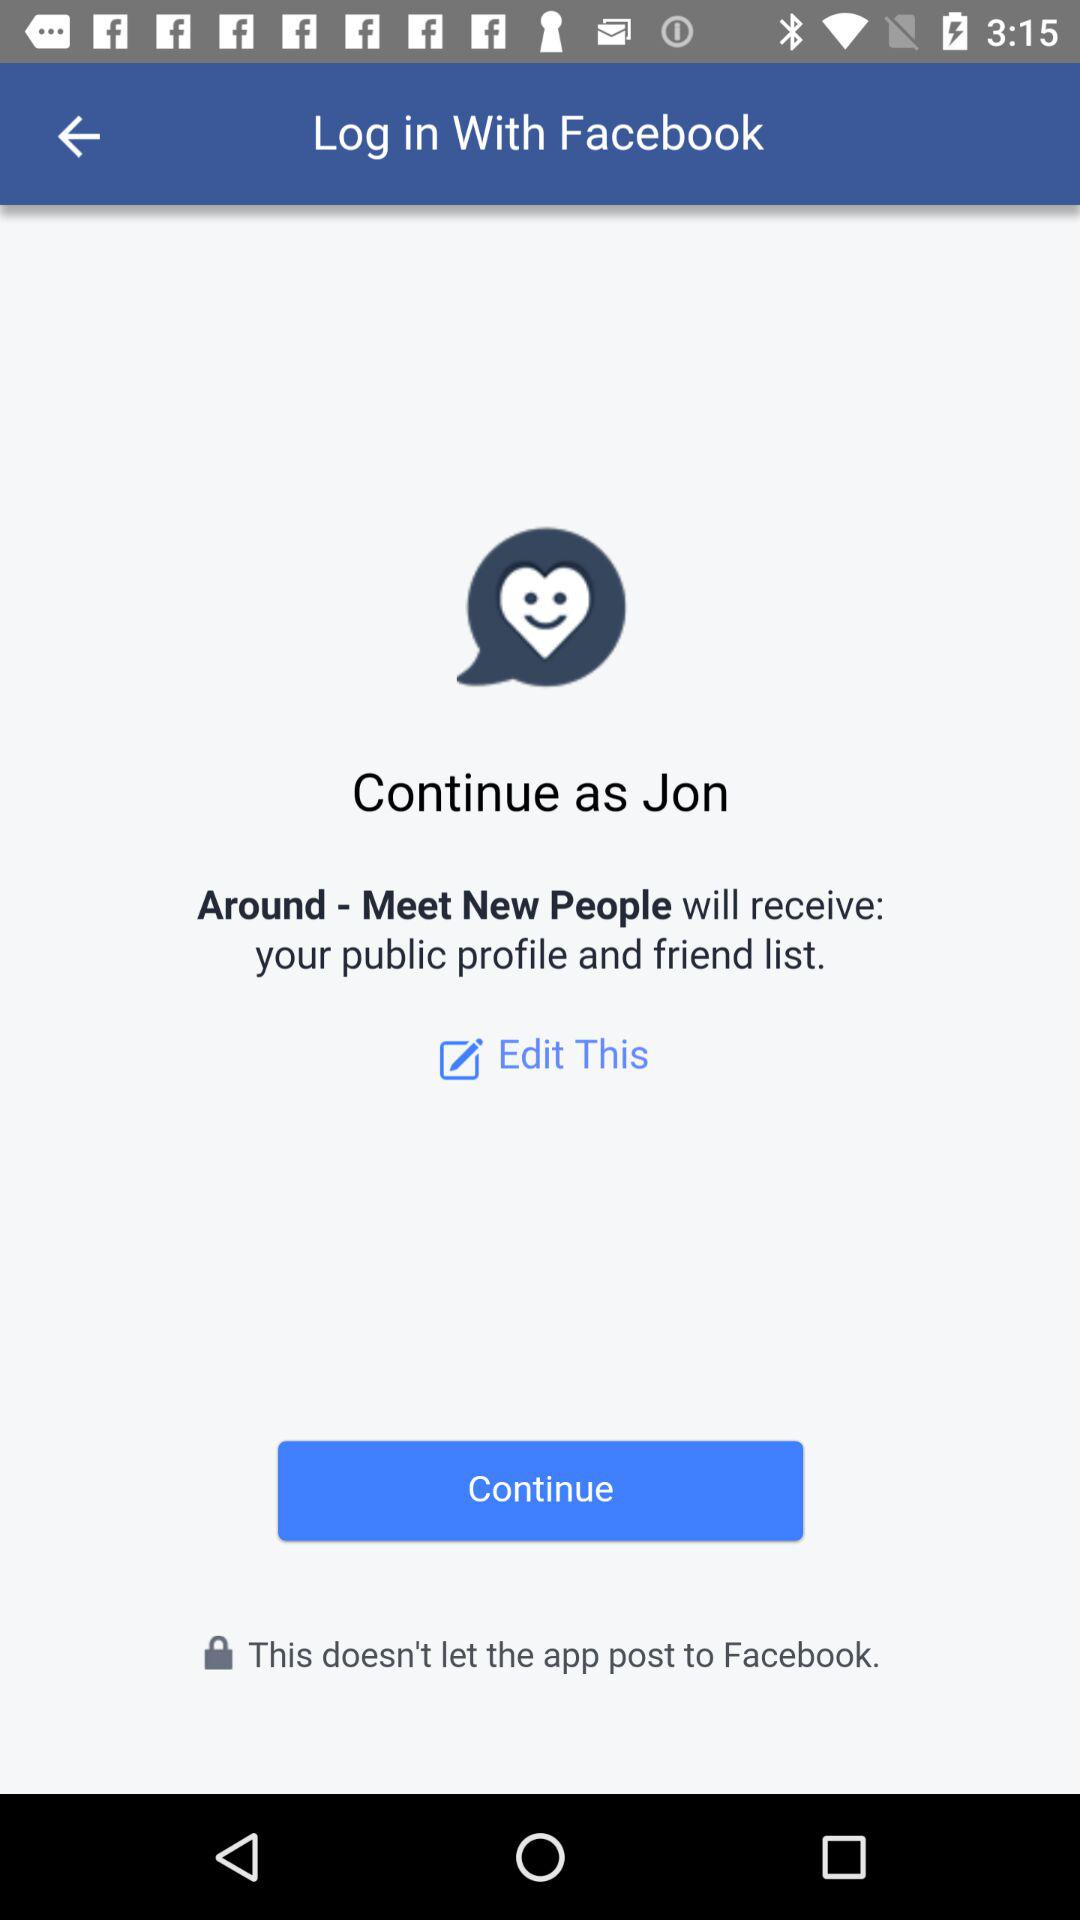What application is asking for permission? The application asking for permission is "Around - Meet New People". 